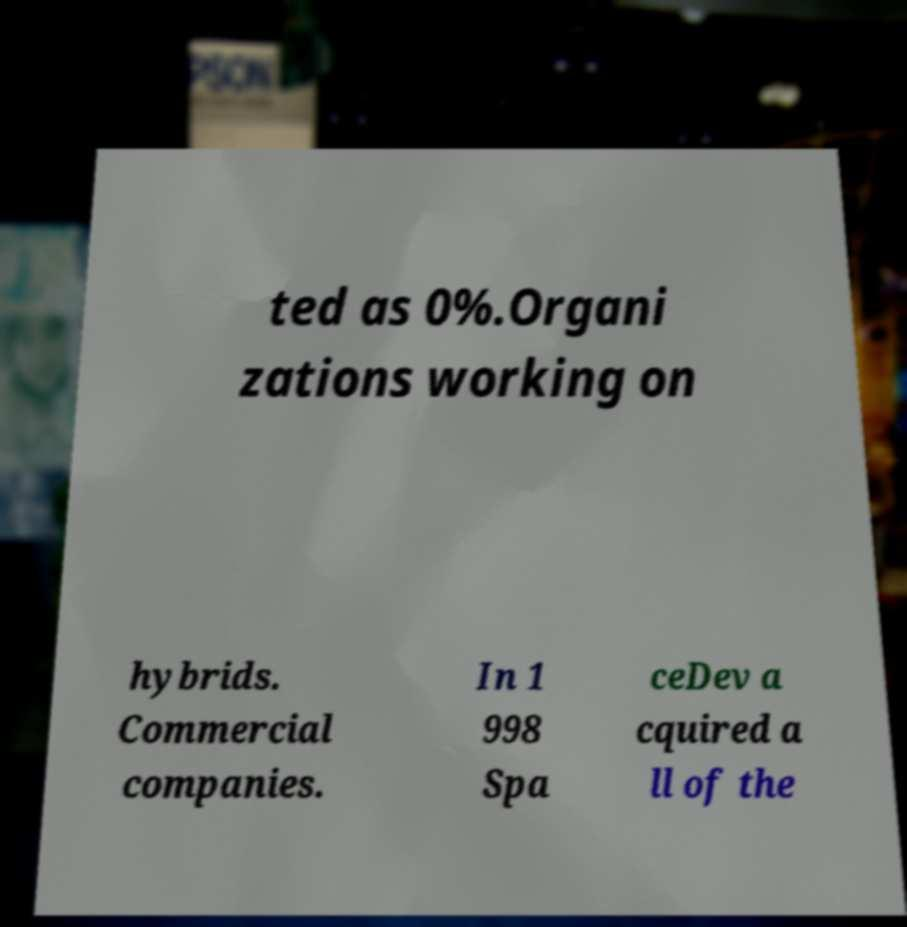Could you extract and type out the text from this image? ted as 0%.Organi zations working on hybrids. Commercial companies. In 1 998 Spa ceDev a cquired a ll of the 